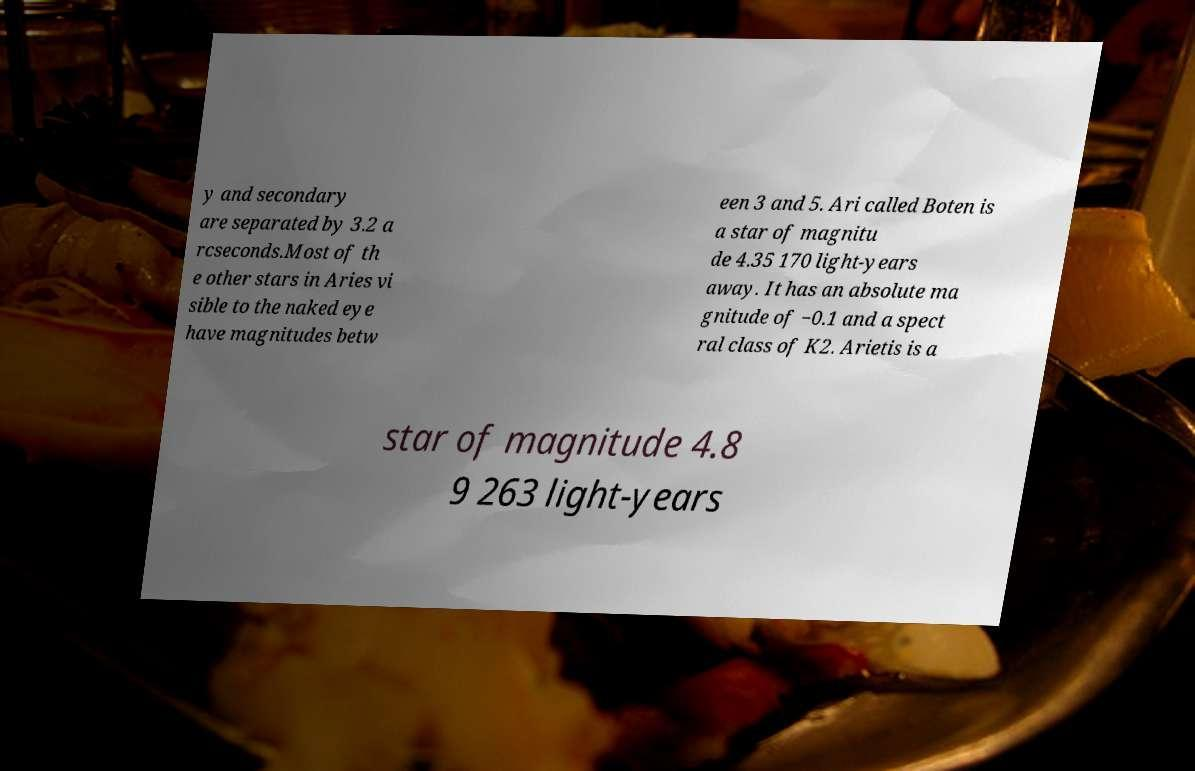Could you assist in decoding the text presented in this image and type it out clearly? y and secondary are separated by 3.2 a rcseconds.Most of th e other stars in Aries vi sible to the naked eye have magnitudes betw een 3 and 5. Ari called Boten is a star of magnitu de 4.35 170 light-years away. It has an absolute ma gnitude of −0.1 and a spect ral class of K2. Arietis is a star of magnitude 4.8 9 263 light-years 